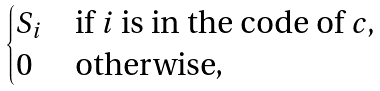<formula> <loc_0><loc_0><loc_500><loc_500>\begin{cases} S _ { i } & \text {if } i \text { is in the code of } c , \\ 0 & \text {otherwise,} \end{cases}</formula> 